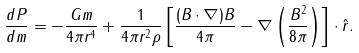<formula> <loc_0><loc_0><loc_500><loc_500>\frac { d P } { d m } = - \frac { G m } { 4 \pi r ^ { 4 } } + \frac { 1 } { 4 \pi r ^ { 2 } \rho } \left [ \frac { ( { B \cdot \nabla } ) { B } } { 4 \pi } - { \nabla } \left ( \frac { B ^ { 2 } } { 8 \pi } \right ) \right ] \cdot { \hat { r } } .</formula> 